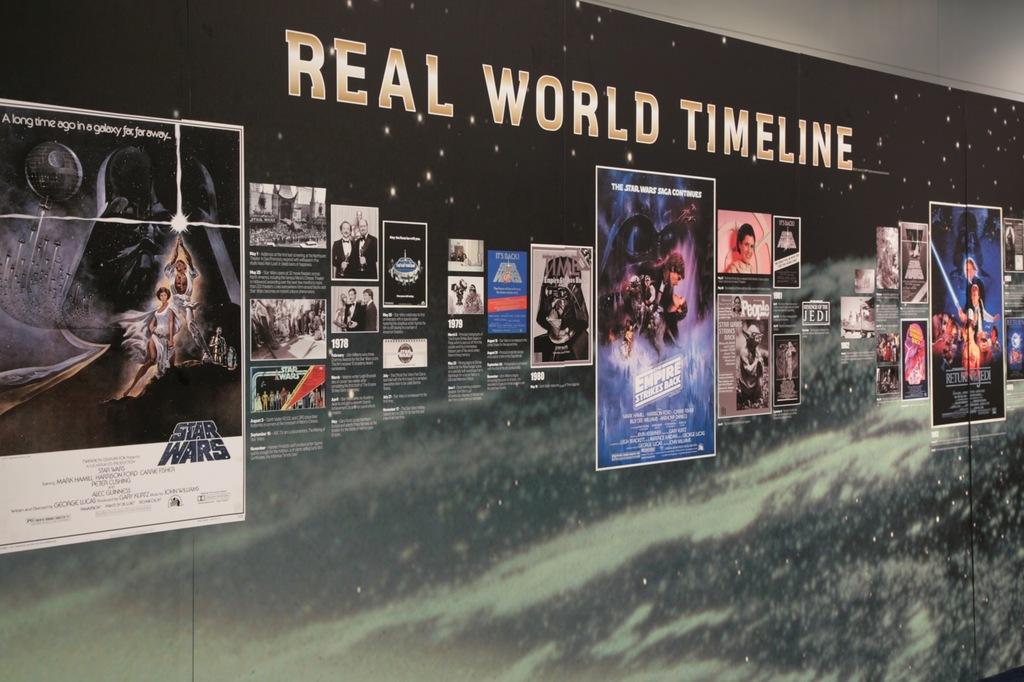Is that a poster of the empire strikes back?
Your response must be concise. Yes. 